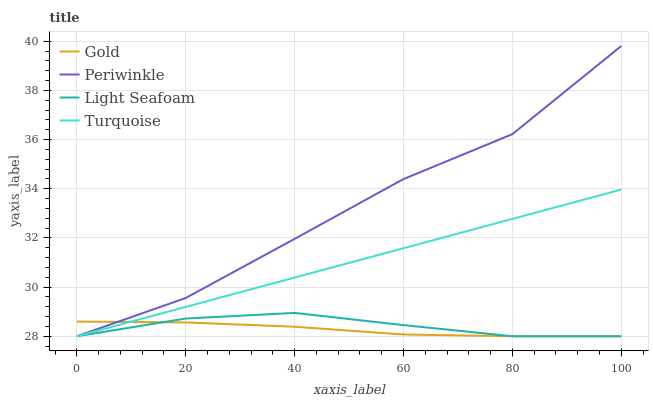Does Gold have the minimum area under the curve?
Answer yes or no. Yes. Does Periwinkle have the maximum area under the curve?
Answer yes or no. Yes. Does Light Seafoam have the minimum area under the curve?
Answer yes or no. No. Does Light Seafoam have the maximum area under the curve?
Answer yes or no. No. Is Turquoise the smoothest?
Answer yes or no. Yes. Is Periwinkle the roughest?
Answer yes or no. Yes. Is Light Seafoam the smoothest?
Answer yes or no. No. Is Light Seafoam the roughest?
Answer yes or no. No. Does Turquoise have the lowest value?
Answer yes or no. Yes. Does Periwinkle have the highest value?
Answer yes or no. Yes. Does Light Seafoam have the highest value?
Answer yes or no. No. Does Periwinkle intersect Gold?
Answer yes or no. Yes. Is Periwinkle less than Gold?
Answer yes or no. No. Is Periwinkle greater than Gold?
Answer yes or no. No. 